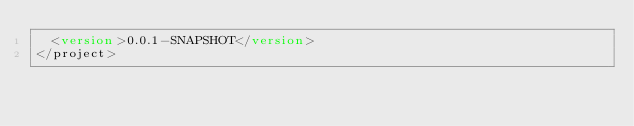<code> <loc_0><loc_0><loc_500><loc_500><_XML_>  <version>0.0.1-SNAPSHOT</version>
</project></code> 